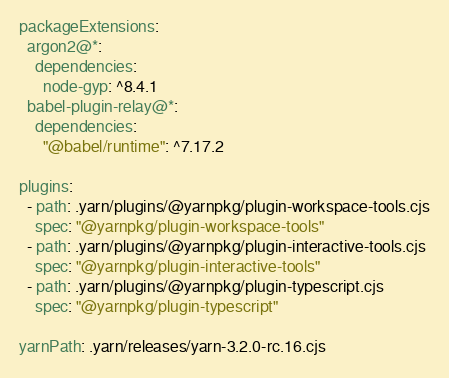<code> <loc_0><loc_0><loc_500><loc_500><_YAML_>packageExtensions:
  argon2@*:
    dependencies:
      node-gyp: ^8.4.1
  babel-plugin-relay@*:
    dependencies:
      "@babel/runtime": ^7.17.2

plugins:
  - path: .yarn/plugins/@yarnpkg/plugin-workspace-tools.cjs
    spec: "@yarnpkg/plugin-workspace-tools"
  - path: .yarn/plugins/@yarnpkg/plugin-interactive-tools.cjs
    spec: "@yarnpkg/plugin-interactive-tools"
  - path: .yarn/plugins/@yarnpkg/plugin-typescript.cjs
    spec: "@yarnpkg/plugin-typescript"

yarnPath: .yarn/releases/yarn-3.2.0-rc.16.cjs
</code> 